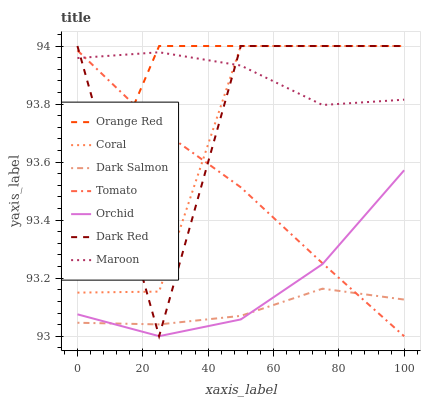Does Dark Salmon have the minimum area under the curve?
Answer yes or no. Yes. Does Orange Red have the maximum area under the curve?
Answer yes or no. Yes. Does Dark Red have the minimum area under the curve?
Answer yes or no. No. Does Dark Red have the maximum area under the curve?
Answer yes or no. No. Is Tomato the smoothest?
Answer yes or no. Yes. Is Dark Red the roughest?
Answer yes or no. Yes. Is Coral the smoothest?
Answer yes or no. No. Is Coral the roughest?
Answer yes or no. No. Does Tomato have the lowest value?
Answer yes or no. Yes. Does Dark Red have the lowest value?
Answer yes or no. No. Does Orange Red have the highest value?
Answer yes or no. Yes. Does Dark Salmon have the highest value?
Answer yes or no. No. Is Dark Salmon less than Orange Red?
Answer yes or no. Yes. Is Maroon greater than Orchid?
Answer yes or no. Yes. Does Dark Salmon intersect Orchid?
Answer yes or no. Yes. Is Dark Salmon less than Orchid?
Answer yes or no. No. Is Dark Salmon greater than Orchid?
Answer yes or no. No. Does Dark Salmon intersect Orange Red?
Answer yes or no. No. 